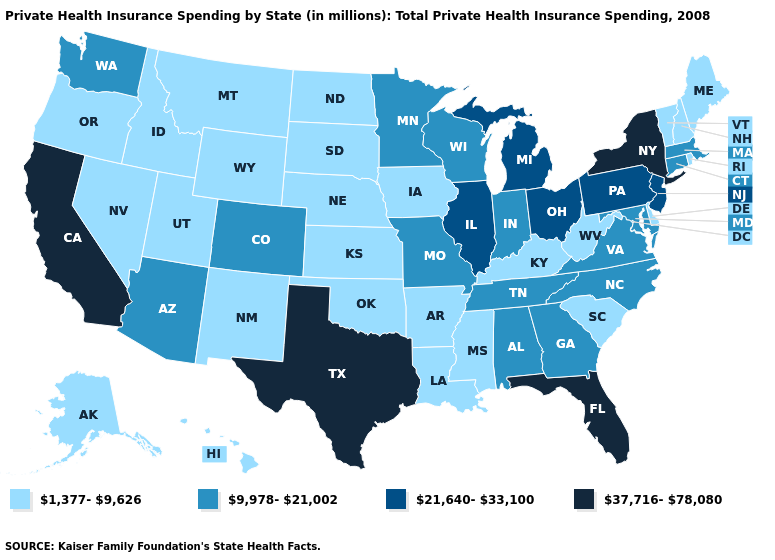Which states have the lowest value in the USA?
Quick response, please. Alaska, Arkansas, Delaware, Hawaii, Idaho, Iowa, Kansas, Kentucky, Louisiana, Maine, Mississippi, Montana, Nebraska, Nevada, New Hampshire, New Mexico, North Dakota, Oklahoma, Oregon, Rhode Island, South Carolina, South Dakota, Utah, Vermont, West Virginia, Wyoming. Does Utah have the same value as Wyoming?
Write a very short answer. Yes. What is the value of Kansas?
Concise answer only. 1,377-9,626. Name the states that have a value in the range 37,716-78,080?
Keep it brief. California, Florida, New York, Texas. What is the lowest value in the West?
Be succinct. 1,377-9,626. Which states have the highest value in the USA?
Short answer required. California, Florida, New York, Texas. What is the value of Oklahoma?
Keep it brief. 1,377-9,626. What is the lowest value in states that border Connecticut?
Concise answer only. 1,377-9,626. Does the map have missing data?
Be succinct. No. Which states hav the highest value in the Northeast?
Be succinct. New York. Which states have the highest value in the USA?
Answer briefly. California, Florida, New York, Texas. Does New Hampshire have a lower value than Utah?
Short answer required. No. What is the value of Vermont?
Write a very short answer. 1,377-9,626. What is the value of Tennessee?
Be succinct. 9,978-21,002. What is the highest value in the USA?
Concise answer only. 37,716-78,080. 